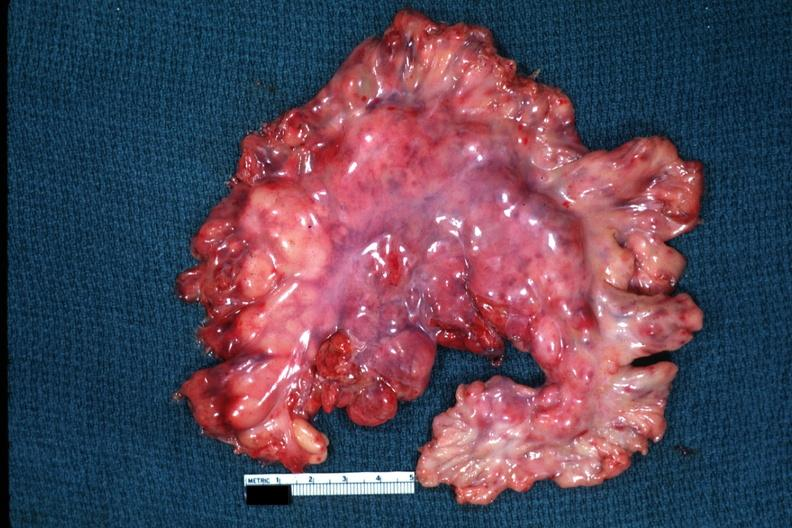s acute lymphocytic leukemia present?
Answer the question using a single word or phrase. Yes 